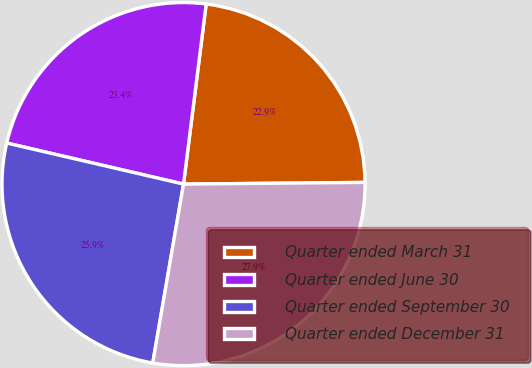Convert chart. <chart><loc_0><loc_0><loc_500><loc_500><pie_chart><fcel>Quarter ended March 31<fcel>Quarter ended June 30<fcel>Quarter ended September 30<fcel>Quarter ended December 31<nl><fcel>22.86%<fcel>23.36%<fcel>25.92%<fcel>27.86%<nl></chart> 